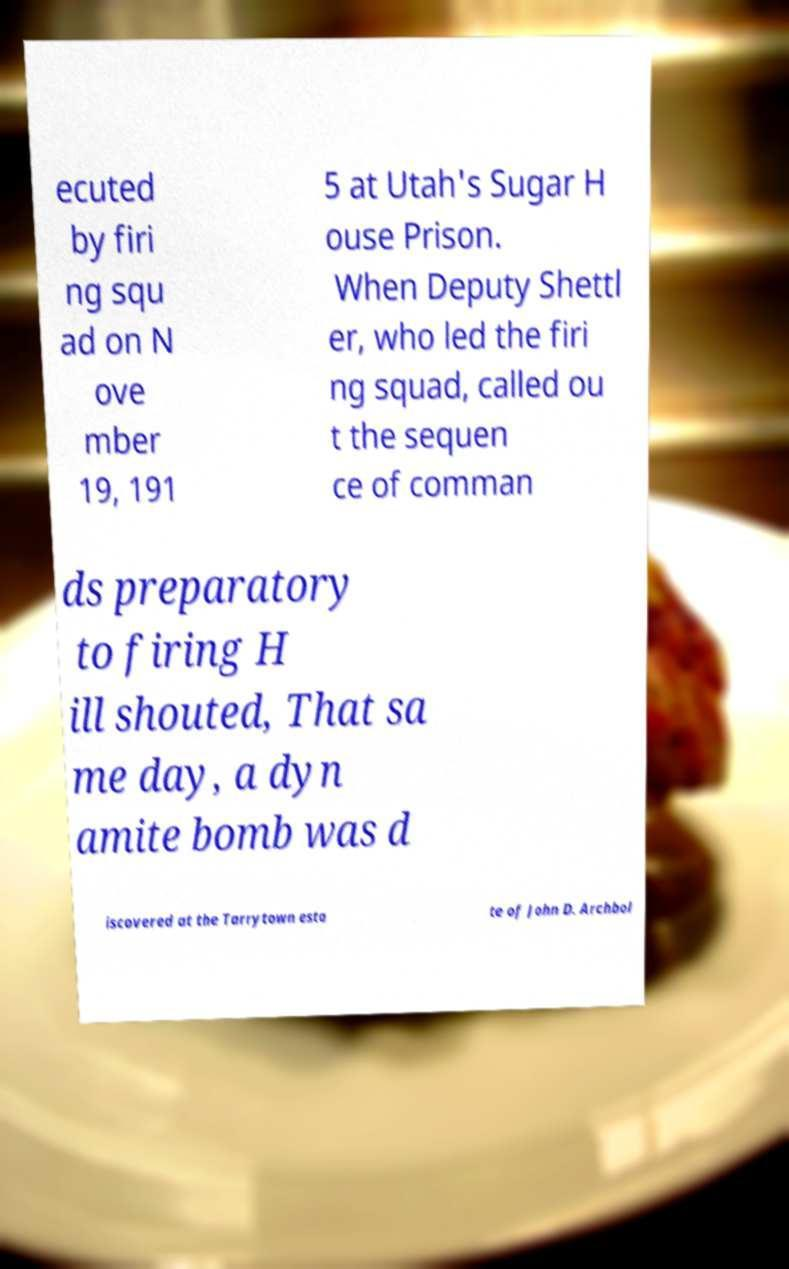Could you assist in decoding the text presented in this image and type it out clearly? ecuted by firi ng squ ad on N ove mber 19, 191 5 at Utah's Sugar H ouse Prison. When Deputy Shettl er, who led the firi ng squad, called ou t the sequen ce of comman ds preparatory to firing H ill shouted, That sa me day, a dyn amite bomb was d iscovered at the Tarrytown esta te of John D. Archbol 